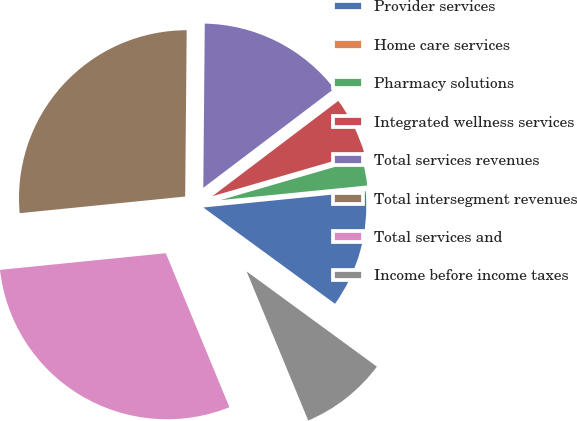<chart> <loc_0><loc_0><loc_500><loc_500><pie_chart><fcel>Provider services<fcel>Home care services<fcel>Pharmacy solutions<fcel>Integrated wellness services<fcel>Total services revenues<fcel>Total intersegment revenues<fcel>Total services and<fcel>Income before income taxes<nl><fcel>11.63%<fcel>0.0%<fcel>2.91%<fcel>5.82%<fcel>14.54%<fcel>26.74%<fcel>29.64%<fcel>8.72%<nl></chart> 